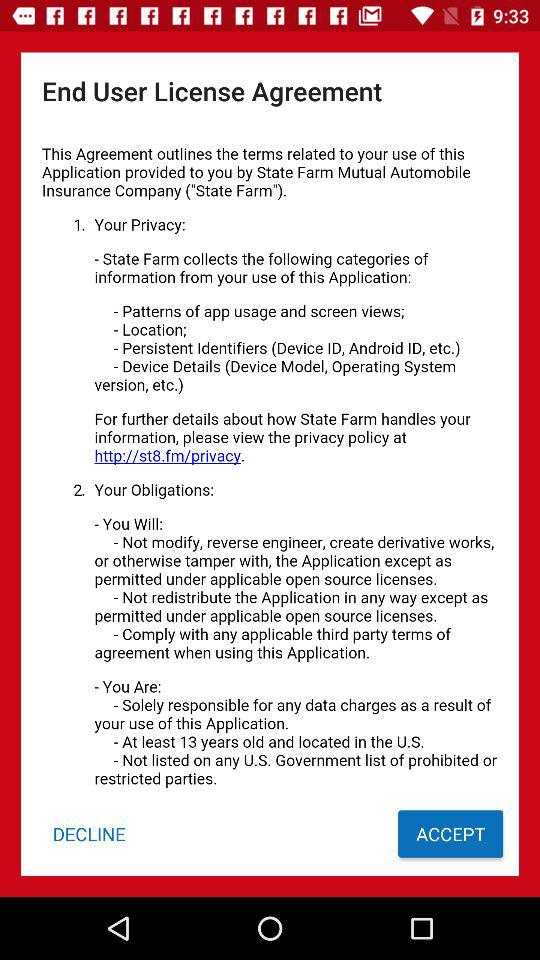What button will be used to agree to the end user license agreement? The button is "ACCEPT". 